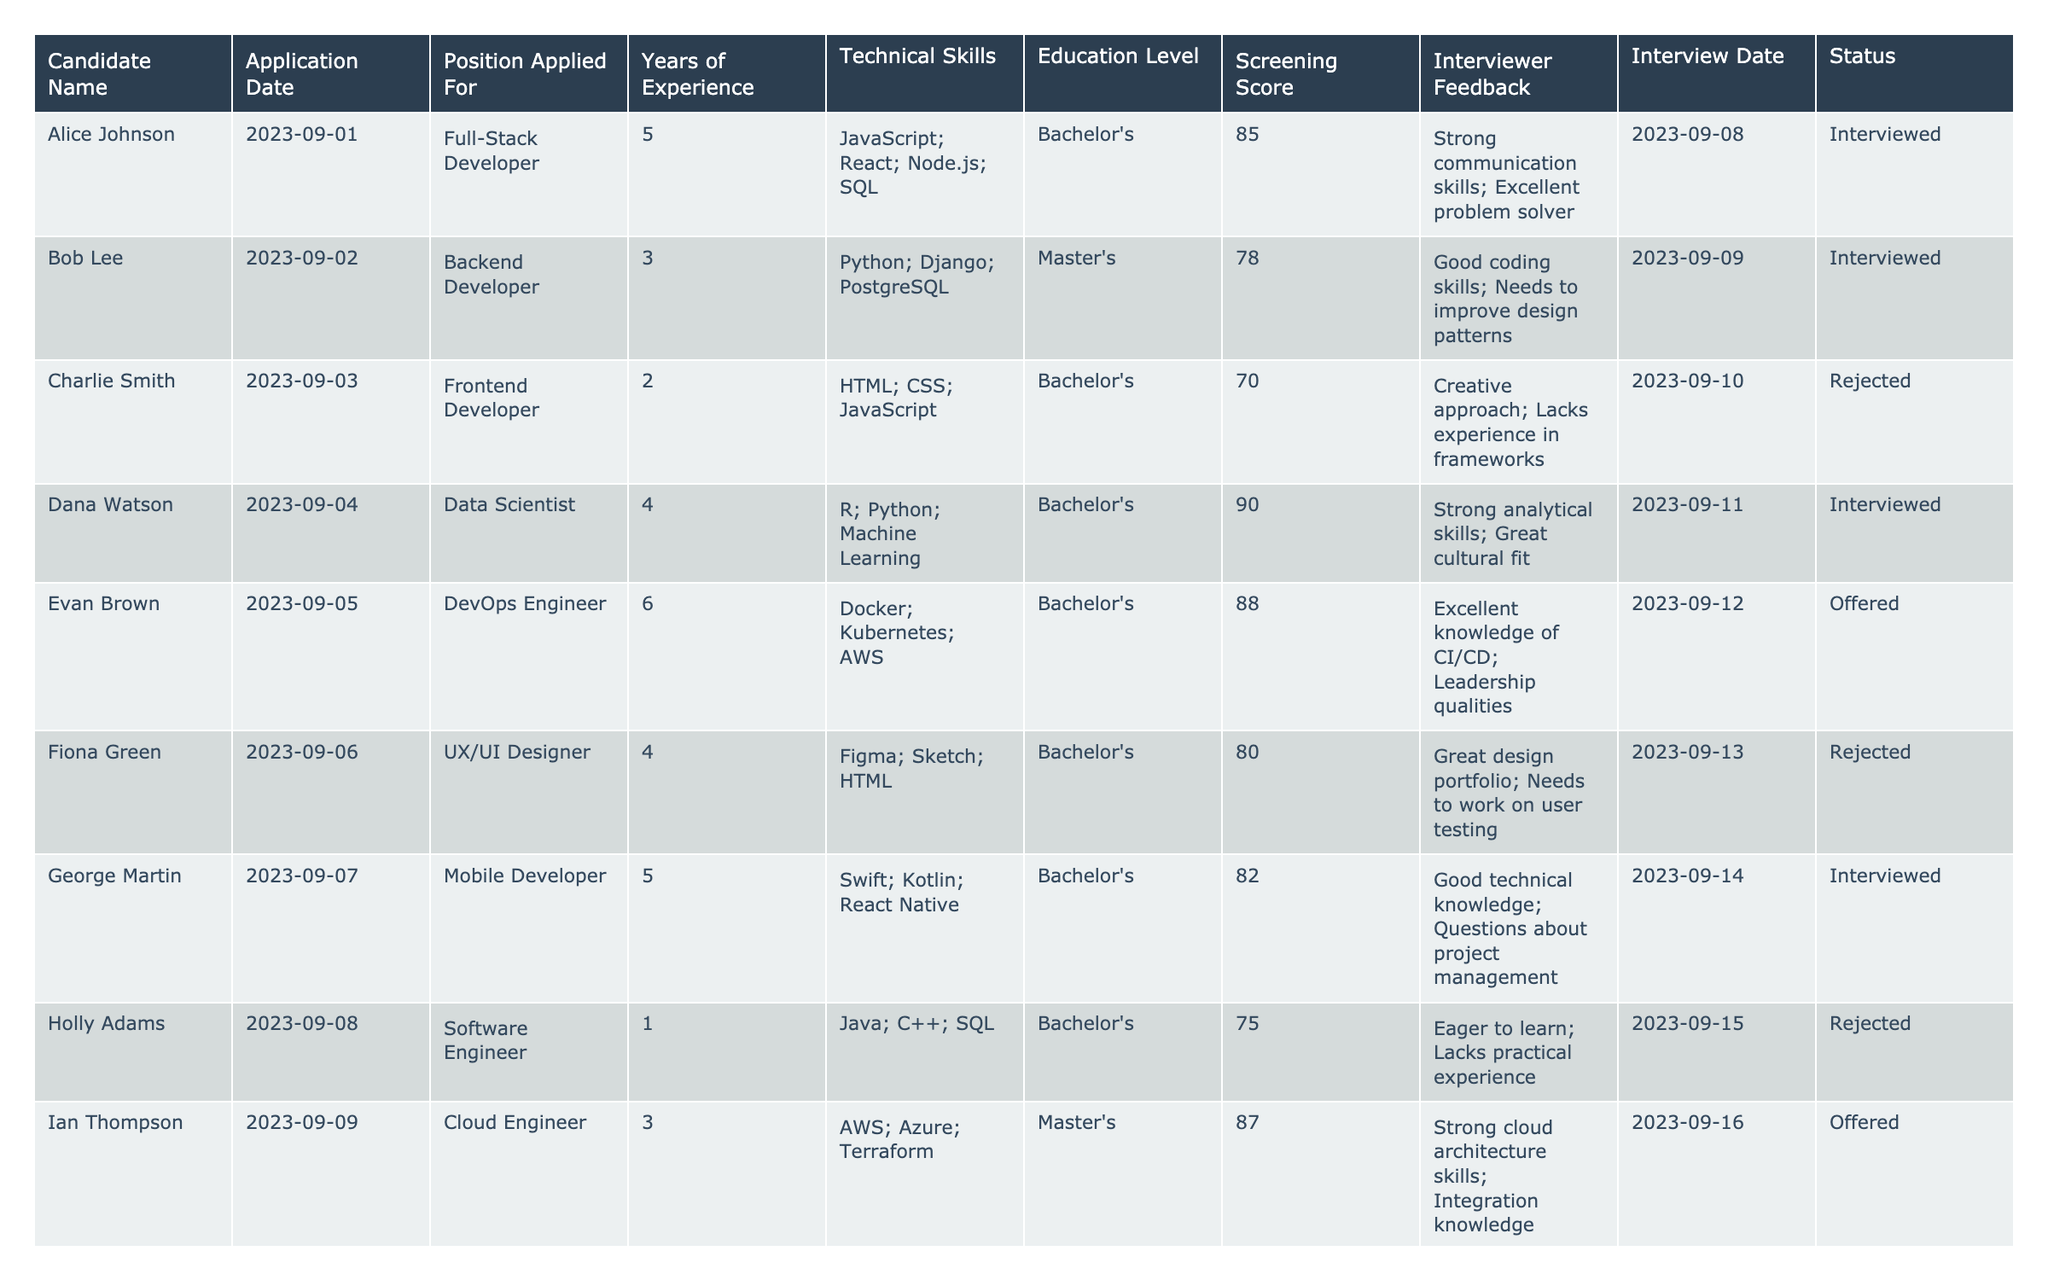What is the highest screening score among the candidates? The screening scores are listed in the table. The highest score is 91, associated with Noah King.
Answer: 91 Who applied for the position of Data Analyst? The table lists the positions along with the candidates' names. Jack Wilson is the candidate who applied for the Data Analyst position.
Answer: Jack Wilson Which candidate has the most years of experience and what is their position? By reviewing the Years of Experience column, Noah King has the most at 7 years, and he applied for the position of Game Developer.
Answer: Noah King, Game Developer What percentage of candidates were offered a position? There are 12 candidates in total, and 5 of them were offered a position. The percentage is (5/12) * 100 = 41.67%.
Answer: 41.67% Is there any candidate with a Master's degree who has been rejected? Looking at the Education Level and Status columns, there are no candidates with a Master's degree who have been rejected.
Answer: No How many candidates have been interviewed without being offered a position? By looking at the Status column, 5 candidates were interviewed but did not receive an offer.
Answer: 5 What is the average screening score of candidates who received an offer? The screening scores of candidates who were offered positions are 88, 84, 89, 91, and 90. The average is (88 + 84 + 89 + 91 + 90) / 5 = 88.4.
Answer: 88.4 Which candidate received the lowest score and what was their interview feedback? The candidate with the lowest screening score is Charlie Smith with a score of 70. The interview feedback mentions a creative approach but lacking experience in frameworks.
Answer: Charlie Smith, score 70 Which technical skills were mentioned by the candidate with the second highest screening score? Laura Watson has the second highest score of 90 and her technical skills listed are R, Python, and Machine Learning.
Answer: R, Python, Machine Learning Are there more candidates who applied for software-related positions or non-software positions? By categorizing the positions, there are 7 software-related applications (including developers and engineers) and 5 non-software applications (including writer, designer, etc.). So, there are more applications for software-related positions.
Answer: Software-related positions 